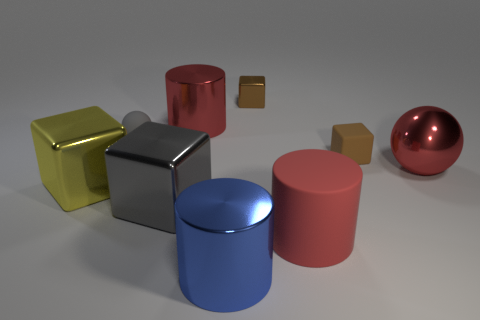Add 1 tiny spheres. How many objects exist? 10 Subtract all spheres. How many objects are left? 7 Subtract all large brown shiny cylinders. Subtract all rubber cylinders. How many objects are left? 8 Add 7 metal cylinders. How many metal cylinders are left? 9 Add 8 cyan blocks. How many cyan blocks exist? 8 Subtract 0 gray cylinders. How many objects are left? 9 